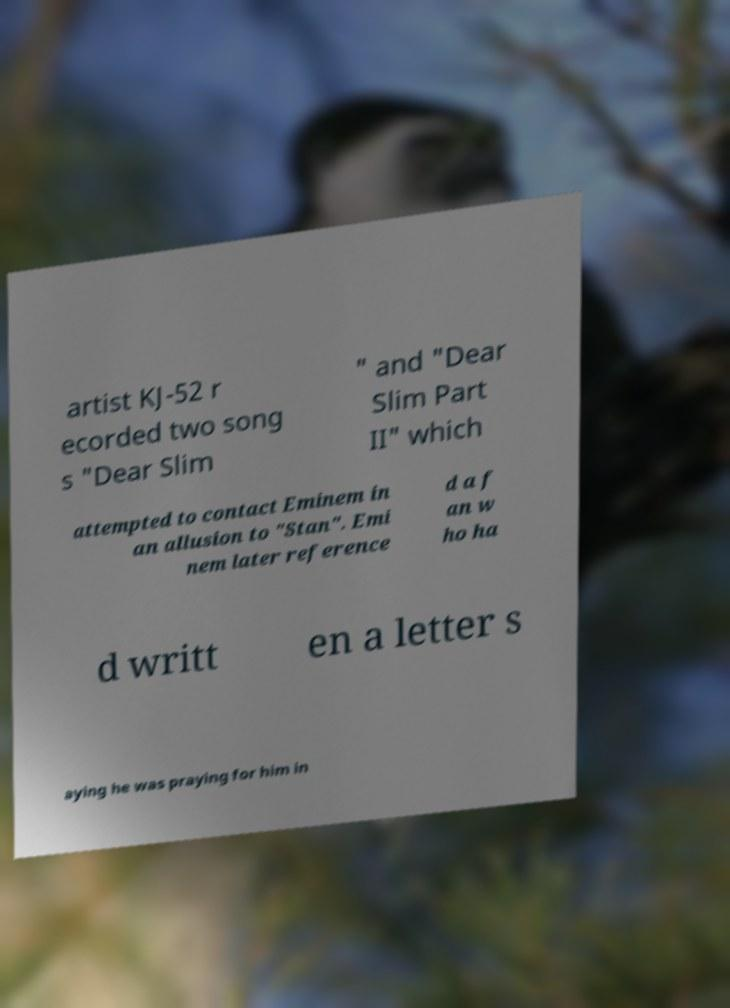I need the written content from this picture converted into text. Can you do that? artist KJ-52 r ecorded two song s "Dear Slim " and "Dear Slim Part II" which attempted to contact Eminem in an allusion to "Stan". Emi nem later reference d a f an w ho ha d writt en a letter s aying he was praying for him in 